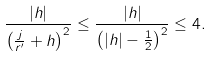Convert formula to latex. <formula><loc_0><loc_0><loc_500><loc_500>\frac { | h | } { \left ( \frac { j } { r ^ { \prime } } + h \right ) ^ { 2 } } \leq \frac { | h | } { \left ( | h | - \frac { 1 } { 2 } \right ) ^ { 2 } } \leq 4 .</formula> 